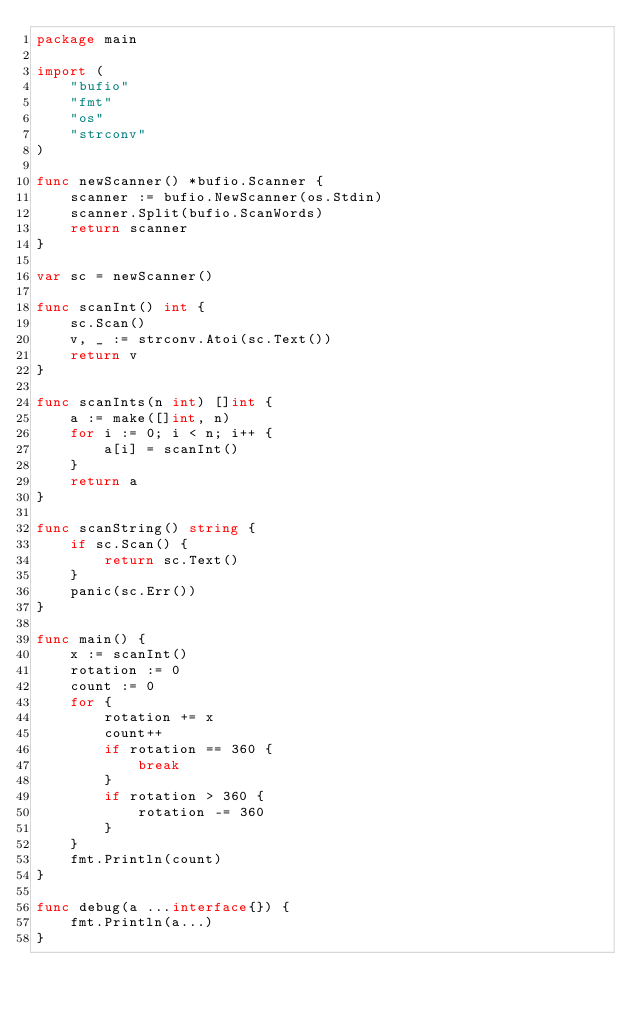<code> <loc_0><loc_0><loc_500><loc_500><_Go_>package main

import (
	"bufio"
	"fmt"
	"os"
	"strconv"
)

func newScanner() *bufio.Scanner {
	scanner := bufio.NewScanner(os.Stdin)
	scanner.Split(bufio.ScanWords)
	return scanner
}

var sc = newScanner()

func scanInt() int {
	sc.Scan()
	v, _ := strconv.Atoi(sc.Text())
	return v
}

func scanInts(n int) []int {
	a := make([]int, n)
	for i := 0; i < n; i++ {
		a[i] = scanInt()
	}
	return a
}

func scanString() string {
	if sc.Scan() {
		return sc.Text()
	}
	panic(sc.Err())
}

func main() {
	x := scanInt()
	rotation := 0
	count := 0
	for {
		rotation += x
		count++
		if rotation == 360 {
			break
		}
		if rotation > 360 {
			rotation -= 360
		}
	}
	fmt.Println(count)
}

func debug(a ...interface{}) {
	fmt.Println(a...)
}
</code> 